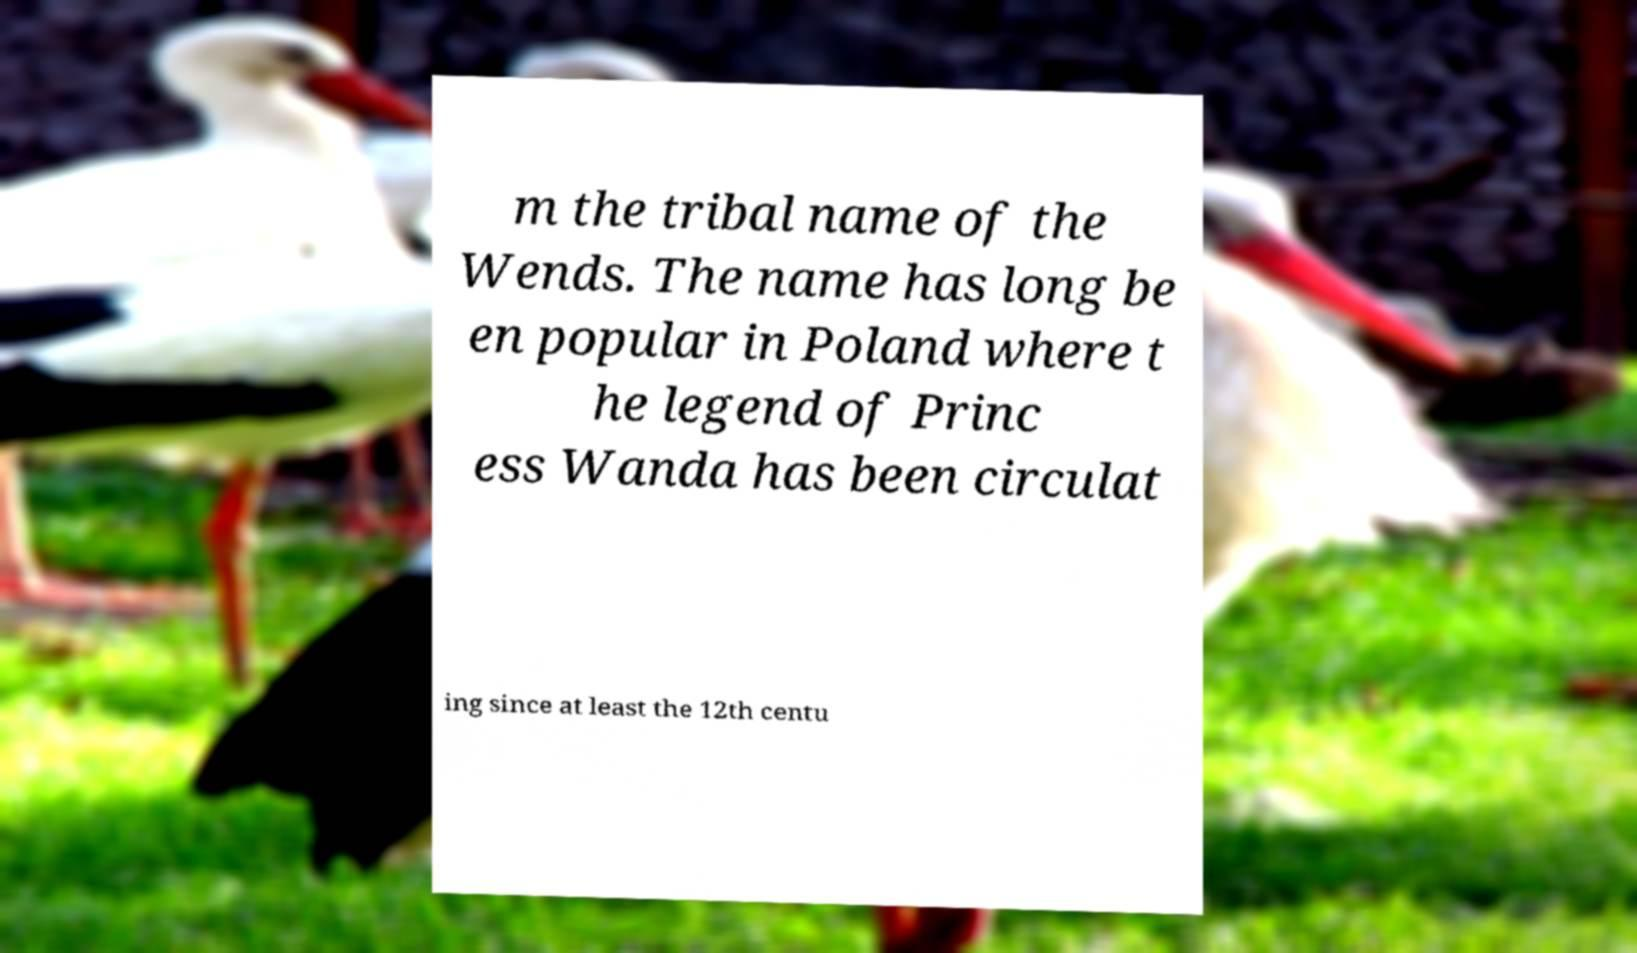Please identify and transcribe the text found in this image. m the tribal name of the Wends. The name has long be en popular in Poland where t he legend of Princ ess Wanda has been circulat ing since at least the 12th centu 